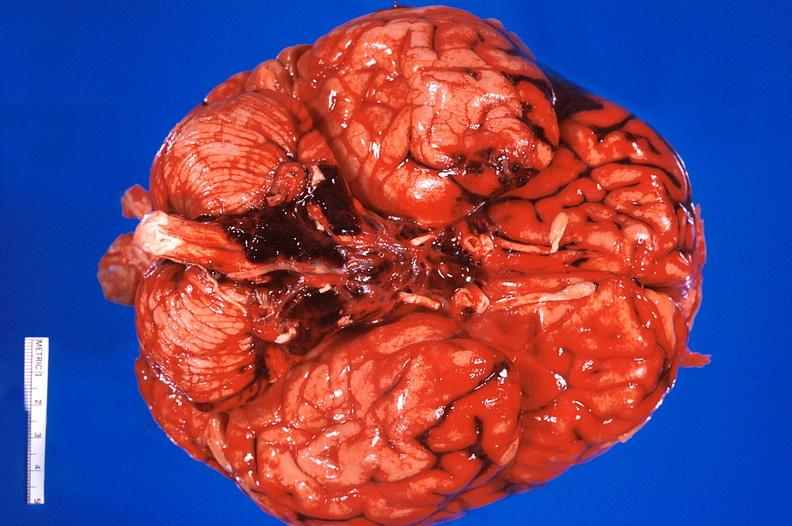s nervous present?
Answer the question using a single word or phrase. Yes 